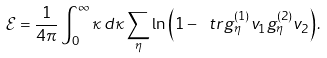<formula> <loc_0><loc_0><loc_500><loc_500>\mathcal { E } = \frac { 1 } { 4 \pi } \int _ { 0 } ^ { \infty } \kappa \, d \kappa \sum _ { \eta } \ln \left ( 1 - \ t r g _ { \eta } ^ { ( 1 ) } v _ { 1 } g _ { \eta } ^ { ( 2 ) } v _ { 2 } \right ) .</formula> 